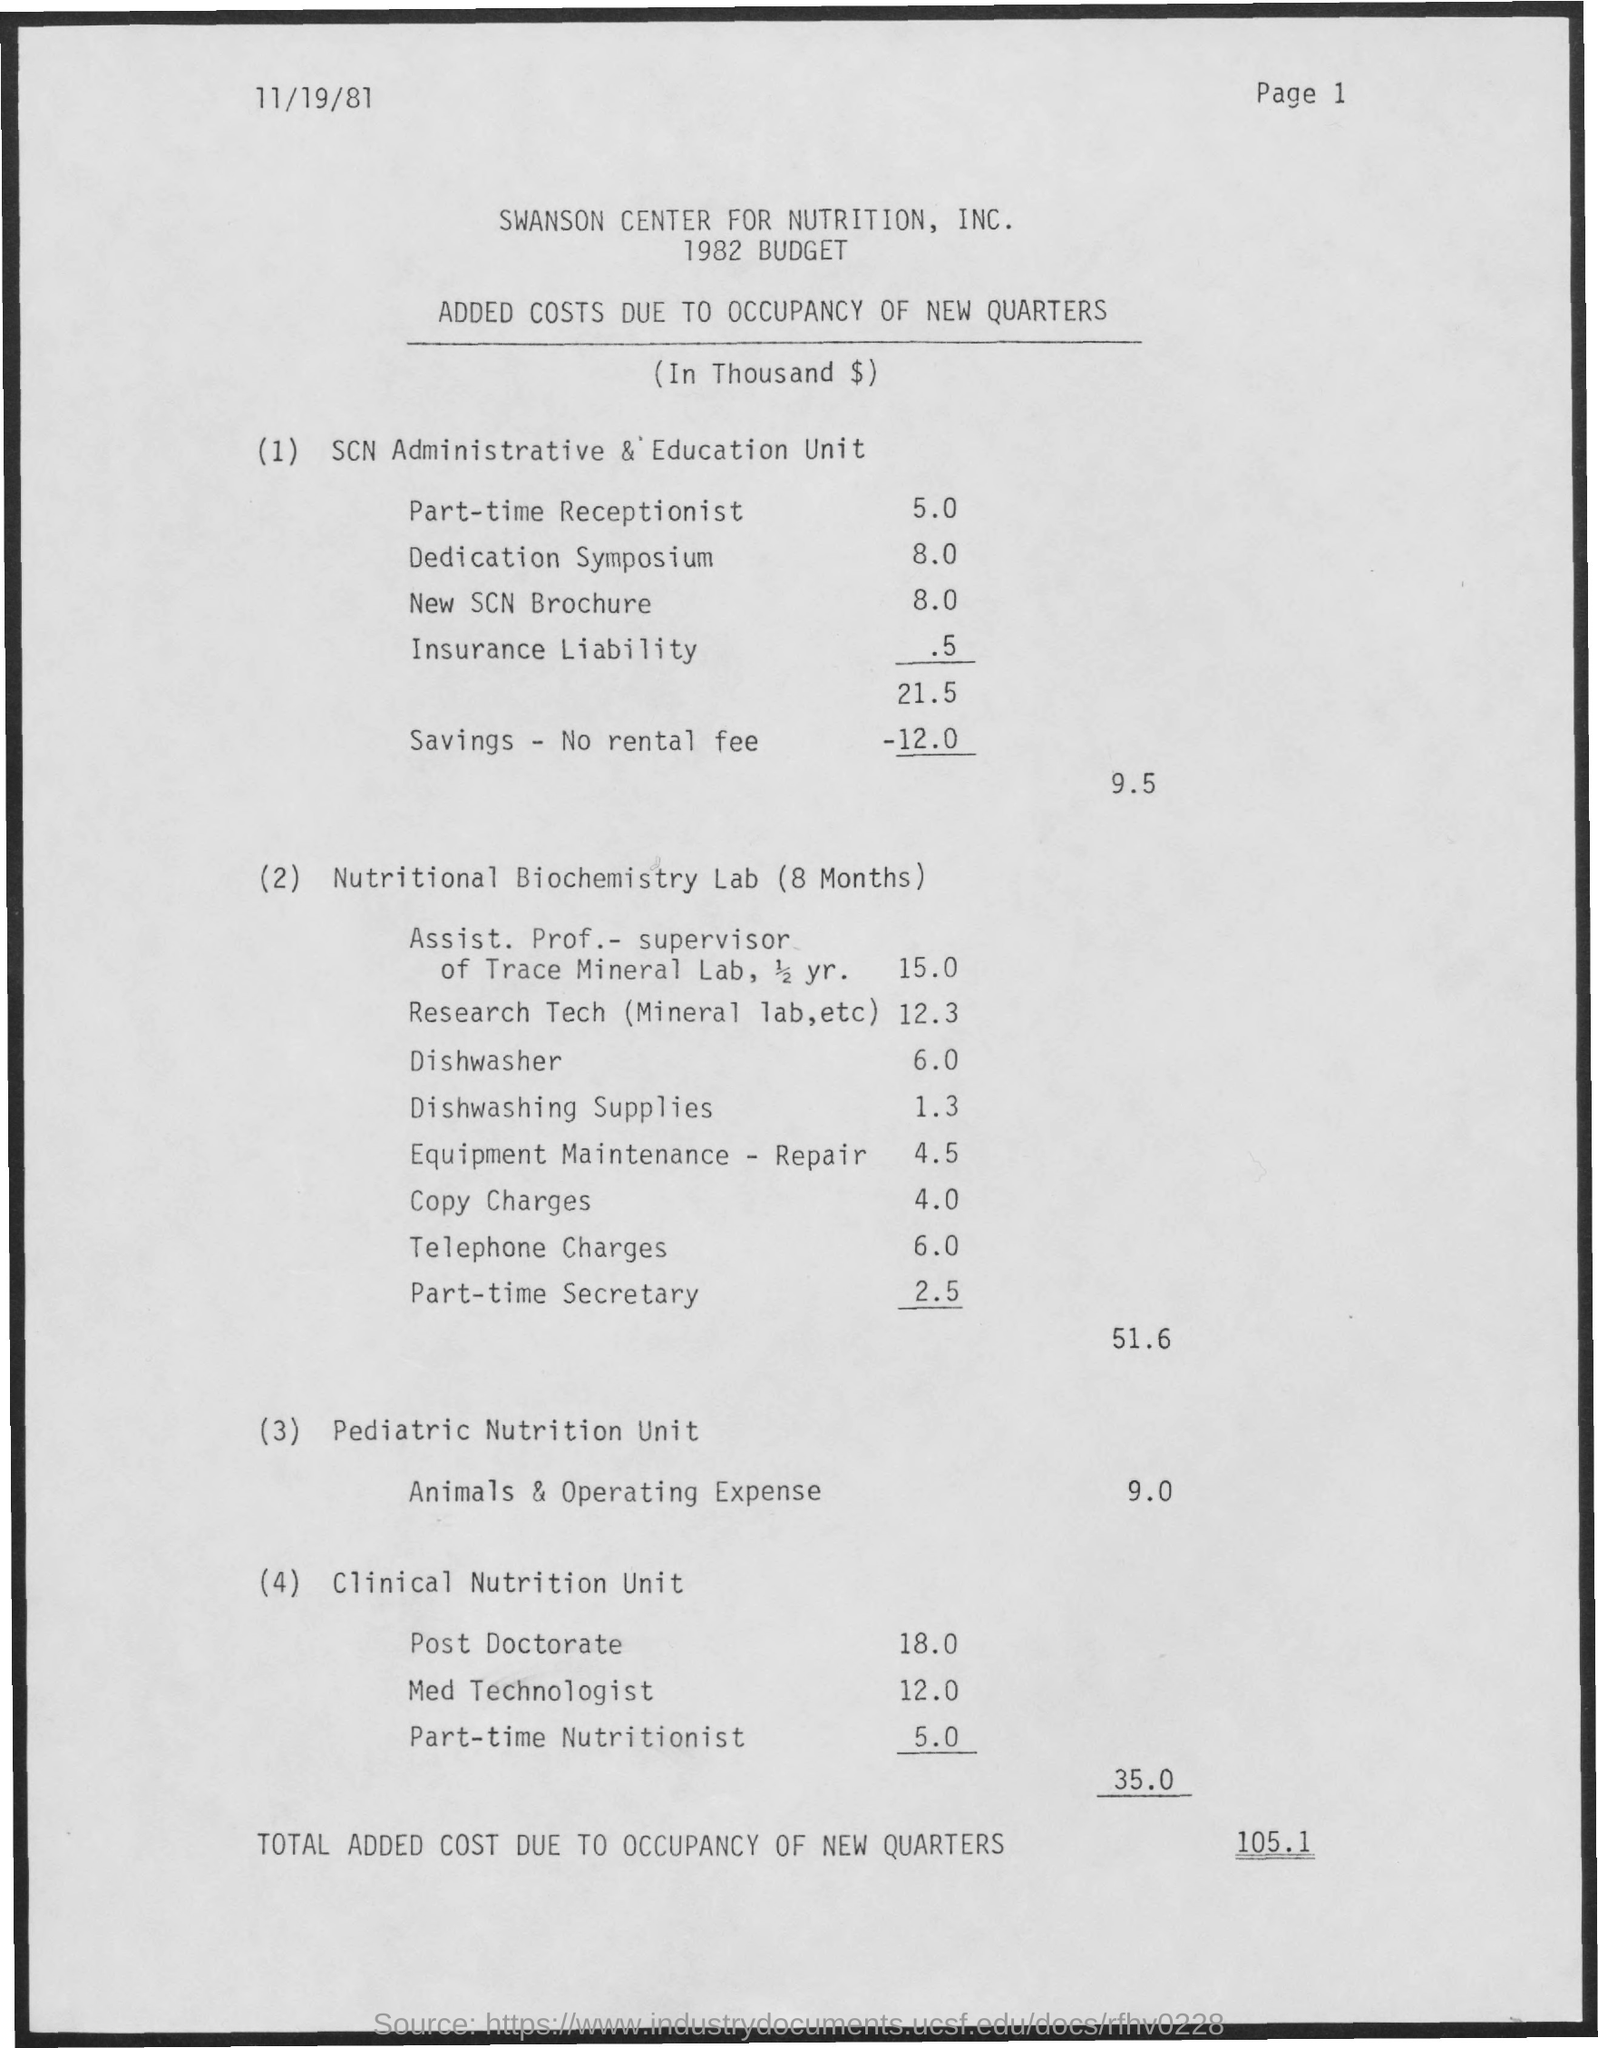Indicate a few pertinent items in this graphic. The added costs due to the occupancy of new quarters for a part-time nutritionist are estimated to be 5.0%. The added costs due to the occupancy of new quarters for a medical technologist is 12.0%. The additional costs incurred due to the occupancy of new quarters for the part-time receptionist total 5.0. The added costs due to the occupancy of new quarters for dishwashing supplies amount to 1.3. The cost of occupying new quarters for the new SCN brochure is 8.0. 